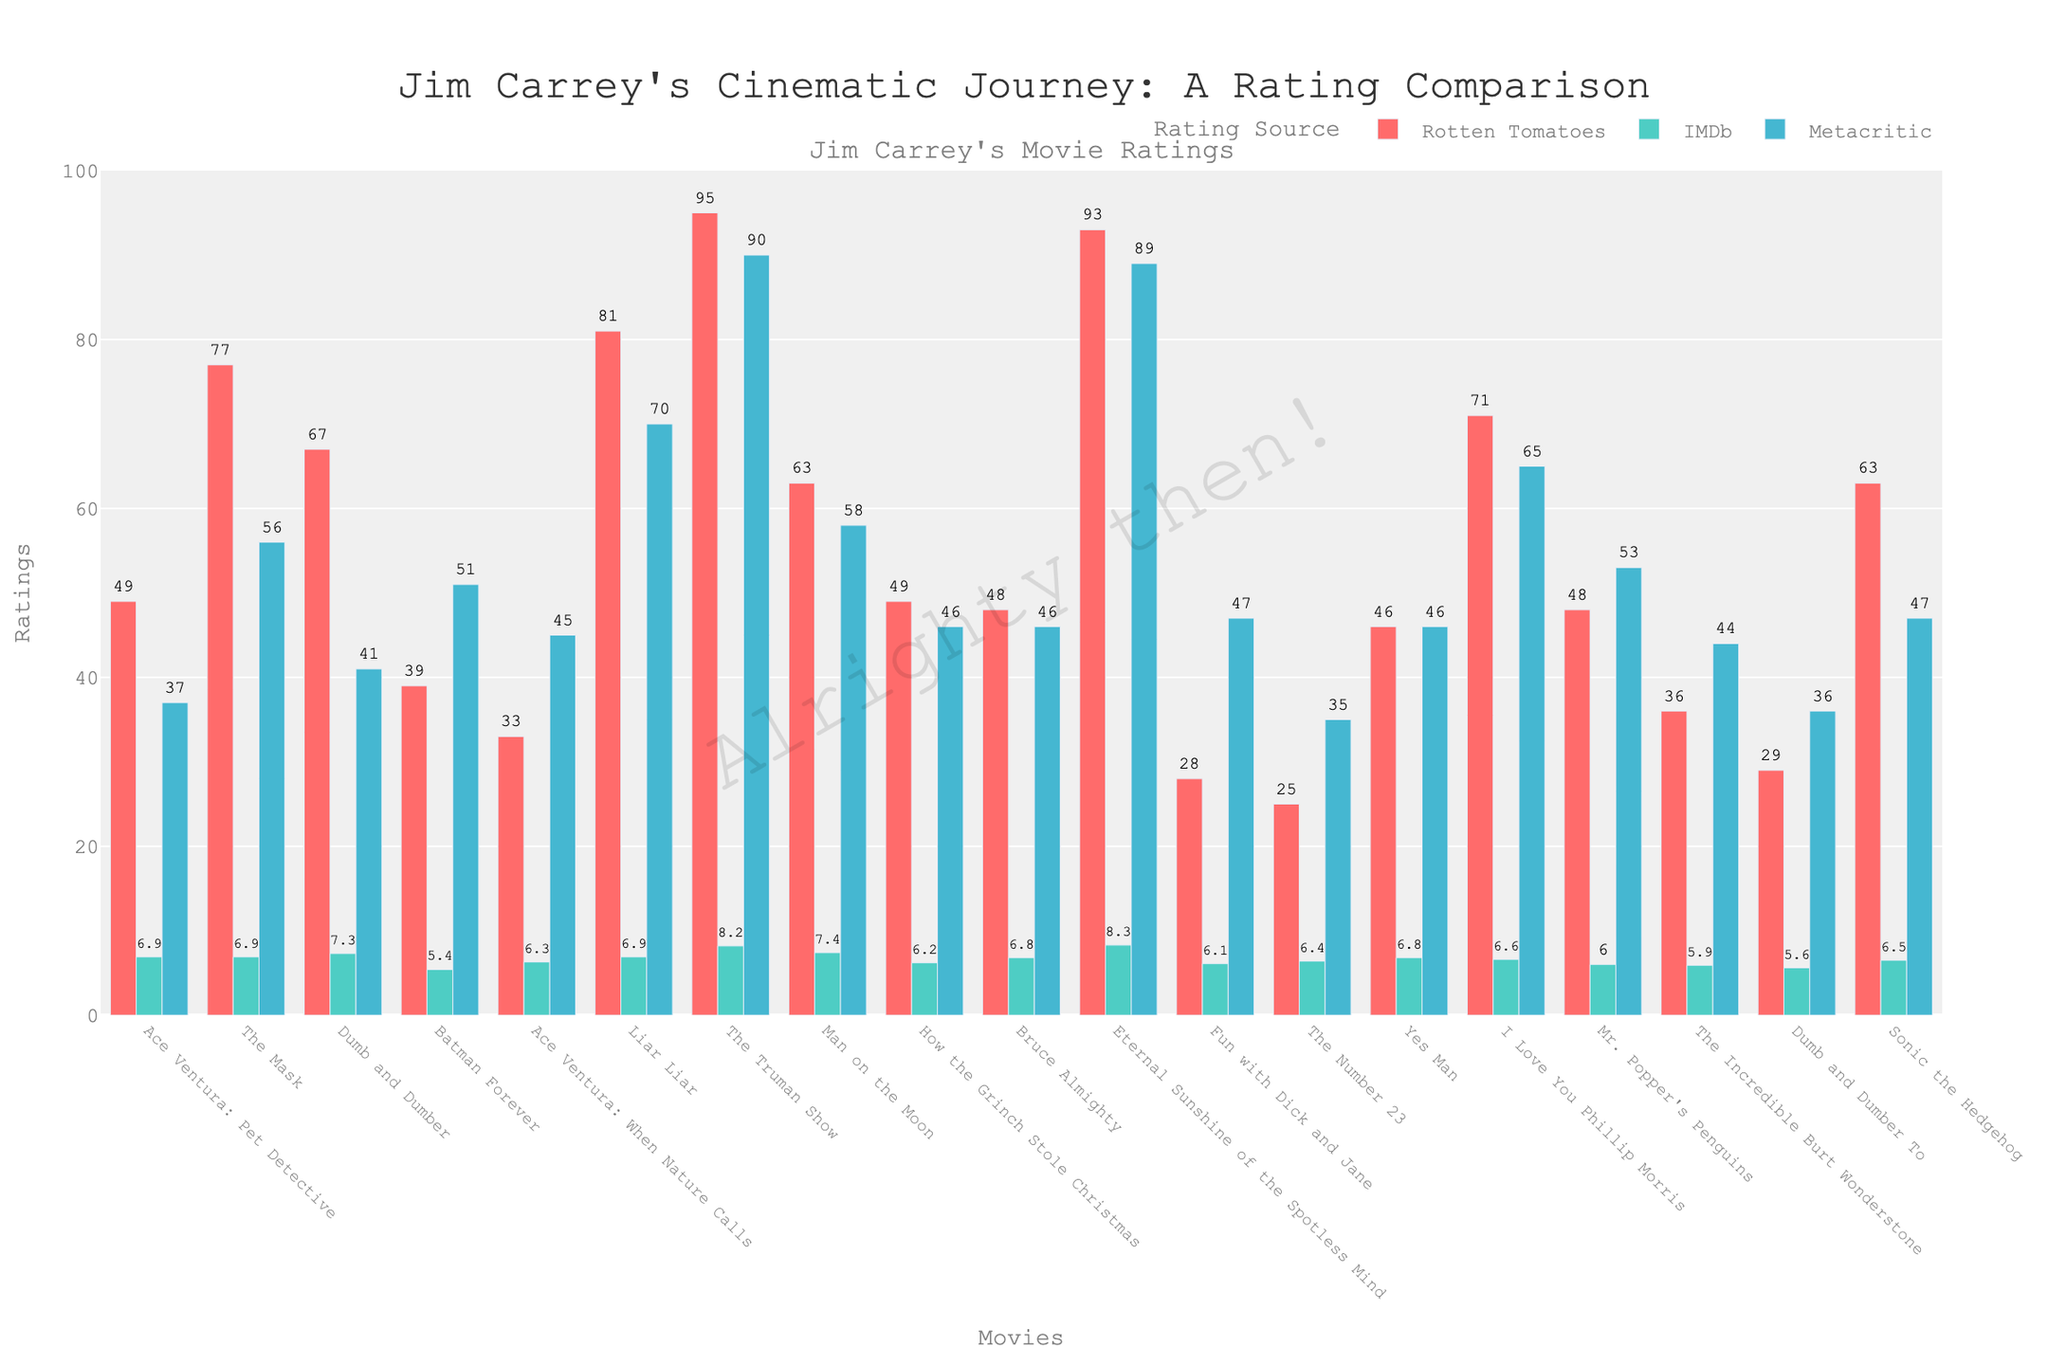What's the highest IMDb rating among Jim Carrey's movies? The highest IMDb rating can be determined by identifying the tallest bar in the IMDb category (green bars). "Eternal Sunshine of the Spotless Mind" has the highest bar in IMDb with a rating of 8.3.
Answer: 8.3 Which movie has the widest rating range between Rotten Tomatoes and Metacritic? Calculating the difference between Rotten Tomatoes and Metacritic ratings for each movie and then finding the maximum difference. "The Truman Show" has Rotten Tomatoes: 95 and Metacritic: 90, a difference of 5.
Answer: The Truman Show What is the sum of IMDb ratings for "Dumb and Dumber" and "Bruce Almighty"? Sum the IMDb ratings of “Dumb and Dumber” (7.3) and “Bruce Almighty” (6.8): 7.3 + 6.8 = 14.1.
Answer: 14.1 Which movie has the lowest rating on Rotten Tomatoes? Identify the shortest bar (red bar) in the Rotten Tomatoes category. "The Number 23" has the shortest bar with a rating of 25.
Answer: The Number 23 Compare the ratings of "Ace Ventura: Pet Detective" and "Ace Ventura: When Nature Calls" across all three platforms. Which one generally received better ratings? For "Ace Ventura: Pet Detective": Rotten Tomatoes (49), IMDb (6.9), Metacritic (37); For "Ace Ventura: When Nature Calls": Rotten Tomatoes (33), IMDb (6.3), Metacritic (45). "Ace Ventura: Pet Detective" has higher Rotten Tomatoes and IMDb ratings, while "Ace Ventura: When Nature Calls" has a higher Metacritic rating. Overall, "Ace Ventura: Pet Detective" generally received better ratings.
Answer: Ace Ventura: Pet Detective How does the Rotten Tomatoes rating for "Eternal Sunshine of the Spotless Mind" compare to that of "Liar Liar"? Compare the heights of the two red bars for "Eternal Sunshine of the Spotless Mind" (93) and "Liar Liar" (81). "Eternal Sunshine of the Spotless Mind" has a higher Rotten Tomatoes rating.
Answer: Eternal Sunshine of the Spotless Mind What is the average Metacritic rating for the movies listed? Sum the Metacritic ratings: 37 + 56 + 41 + 51 + 45 + 70 + 90 + 58 + 46 + 46 + 89 + 47 + 35 + 46 + 65 + 53 + 44 + 36 + 47 = 1006. Average = 1006 / 19 = 52.95.
Answer: 52.95 Which movie has the closest ratings across all three platforms? Looking for the movie where IMDb, Rotten Tomatoes, and Metacritic ratings are closest in value. "Bruce Almighty" with Rotten Tomatoes (48), IMDb (6.8), and Metacritic (46) has closely aligned values.
Answer: Bruce Almighty What is the difference between the IMDb rating of "Man on the Moon" and "Sonic the Hedgehog"? Subtract the IMDb rating of "Sonic the Hedgehog" (6.5) from "Man on the Moon" (7.4): 7.4 - 6.5 = 0.9.
Answer: 0.9 What's the median Metacritic rating among Jim Carrey's movies? Organize the Metacritic ratings in numerical order: 35, 36, 37, 41, 44, 45, 46, 46, 46, 47, 47, 51, 53, 56, 58, 65, 70, 89, 90. The median is the middle value, which is 47.
Answer: 47 